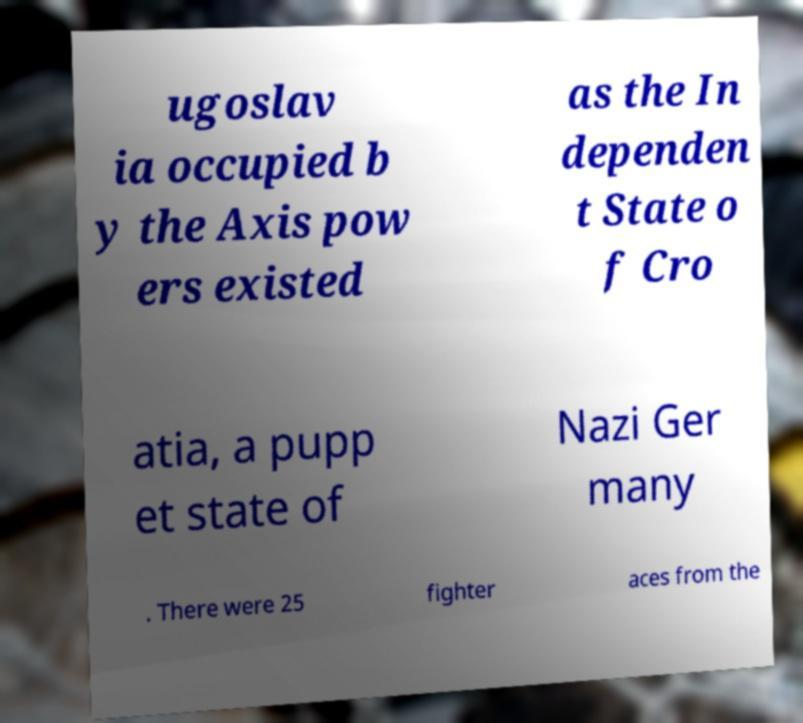For documentation purposes, I need the text within this image transcribed. Could you provide that? ugoslav ia occupied b y the Axis pow ers existed as the In dependen t State o f Cro atia, a pupp et state of Nazi Ger many . There were 25 fighter aces from the 